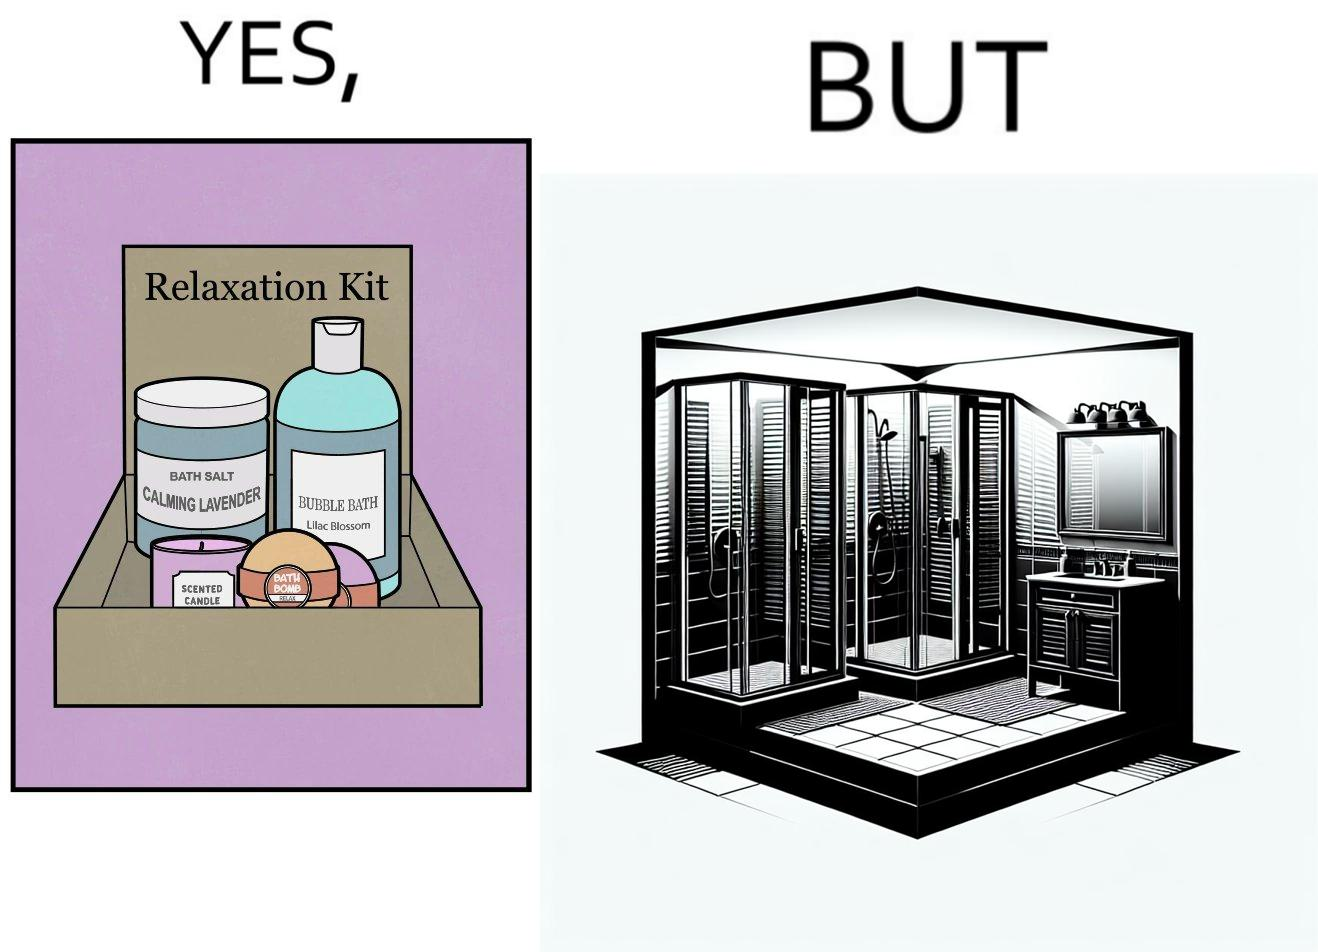Provide a description of this image. The image is ironical, as the relaxation kit is meant to relax and calm down the person using it during a bath, but the showering area is an enclosed space, which might instead tense up someone, especially if the person is claustrophobic. 